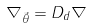<formula> <loc_0><loc_0><loc_500><loc_500>\nabla _ { \vec { \theta } } = D _ { d } \nabla</formula> 